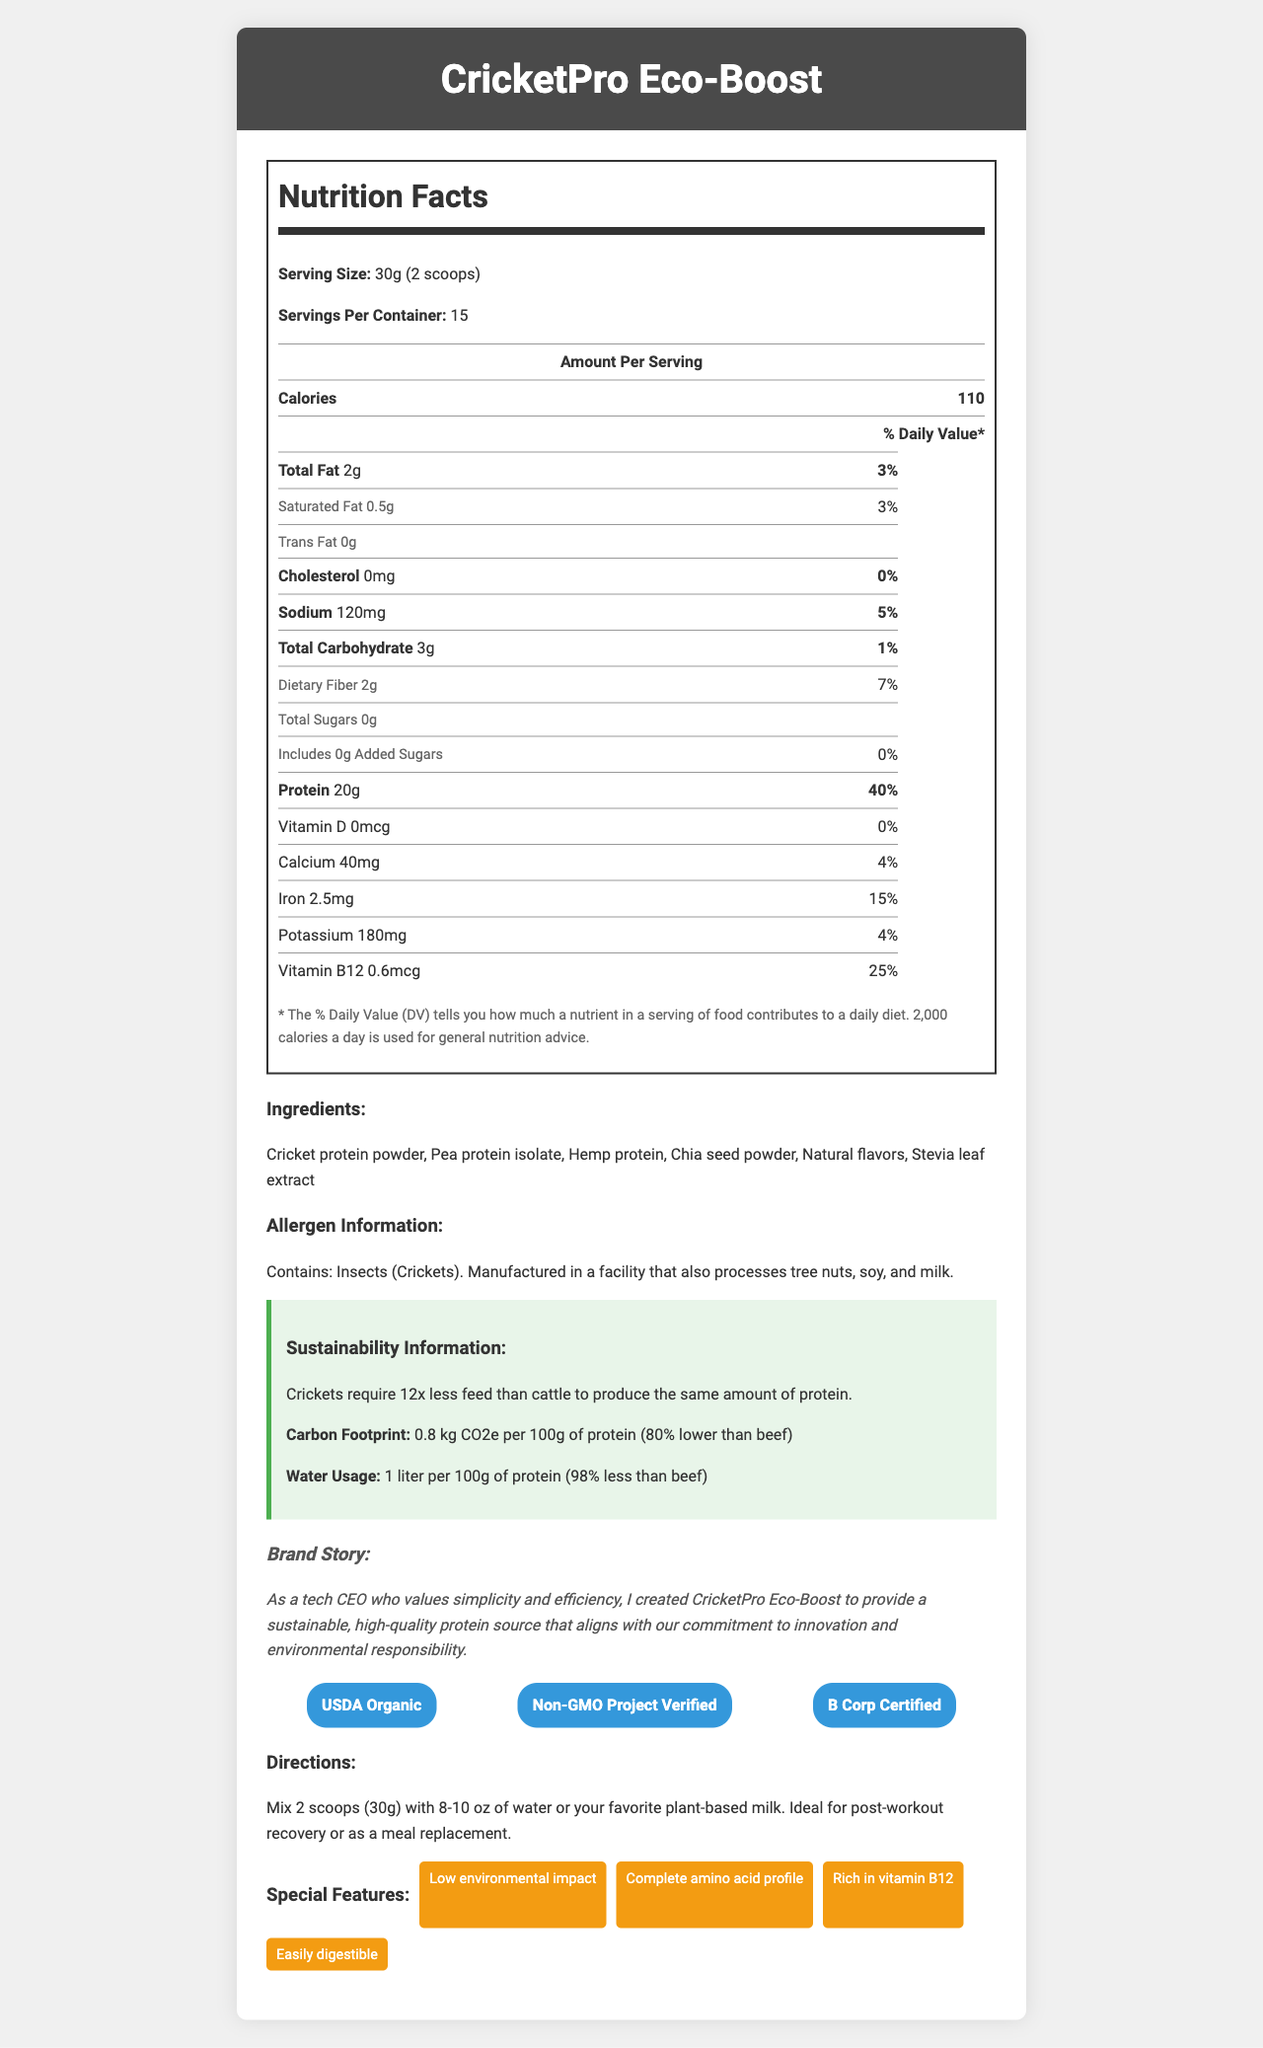what is the serving size of CricketPro Eco-Boost? The serving size is explicitly mentioned in the nutrition label as "30g (2 scoops)".
Answer: 30g (2 scoops) how many calories are there per serving? The nutrition label lists "Calories" as 110 per serving.
Answer: 110 what percentage of daily protein is provided per serving? The document states that each serving provides 40% of the daily value for protein.
Answer: 40% which certifications does the CricketPro Eco-Boost have? The certifications are listed under a section titled "certifications".
Answer: USDA Organic, Non-GMO Project Verified, B Corp Certified does one serving of CricketPro Eco-Boost contain any added sugars? The information on the nutrition label shows "Added Sugars: 0g" with a daily value of 0%.
Answer: No how much sodium is in one serving? The nutrition label states that one serving contains 120mg of sodium.
Answer: 120mg which ingredient is not included in the CricketPro Eco-Boost? A. Pea protein isolate B. Hemp protein C. Soy protein D. Chia seed powder The listed ingredients are "Cricket protein powder, Pea protein isolate, Hemp protein, Chia seed powder, Natural flavors, Stevia leaf extract". Soy protein is not listed.
Answer: C what is the water usage to produce 100g of protein from crickets? A. 1 liter B. 5 liters C. 10 liters D. 15 liters The sustainability section states "Water Usage: 1 liter per 100g of protein". Therefore, the correct answer is 1 liter.
Answer: A is CricketPro Eco-Boost manufactured in a facility that processes tree nuts? The allergen information mentions "Manufactured in a facility that also processes tree nuts, soy, and milk".
Answer: Yes summarize the main idea of the CricketPro Eco-Boost Nutrition Facts document. The summary encapsulates all the key sections from the provided details about the product.
Answer: The document presents the nutritional information, ingredients, allergen info, sustainability credentials, brand story, certifications, and use directions for CricketPro Eco-Boost, a plant-based sustainable protein powder made from crickets. how much vitamin D is in a serving? The nutrition label lists "Vitamin D: 0mcg", indicating that there is no Vitamin D in a serving.
Answer: 0mcg what is the carbon footprint of producing 100g of protein from crickets? The sustainability section lists "Carbon Footprint: 0.8 kg CO2e per 100g of protein".
Answer: 0.8 kg CO2e what is the daily value percentage of iron provided per serving? The nutrition label indicates that each serving provides 15% of the daily value for iron.
Answer: 15% what is the relationship between this CEO's persona and the brand story of CricketPro Eco-Boost? The brand story mentions a tech CEO who values simplicity and efficiency but does not provide details specifically tying it to the given persona of the high-tech CEO who wears gray t-shirts.
Answer: Cannot be determined 